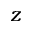Convert formula to latex. <formula><loc_0><loc_0><loc_500><loc_500>z</formula> 